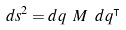Convert formula to latex. <formula><loc_0><loc_0><loc_500><loc_500>d s ^ { 2 } = d q \ M \ d q ^ { \intercal }</formula> 